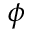<formula> <loc_0><loc_0><loc_500><loc_500>\phi</formula> 